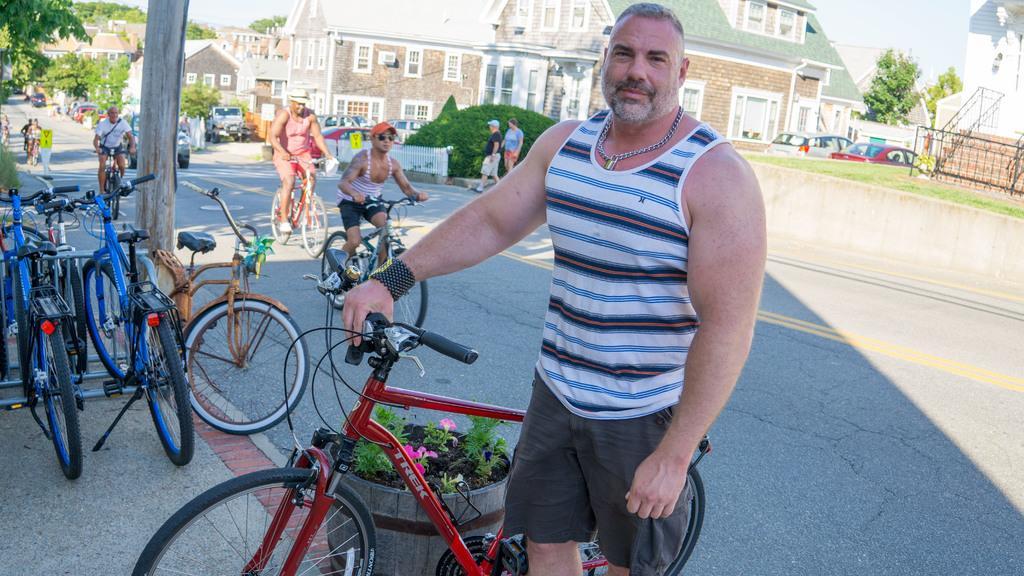In one or two sentences, can you explain what this image depicts? In this image i can see man standing and holding bi-cycle i can also see a plant, at the back ground i can see few persons riding bicycle, a tree, a building and a sky. 